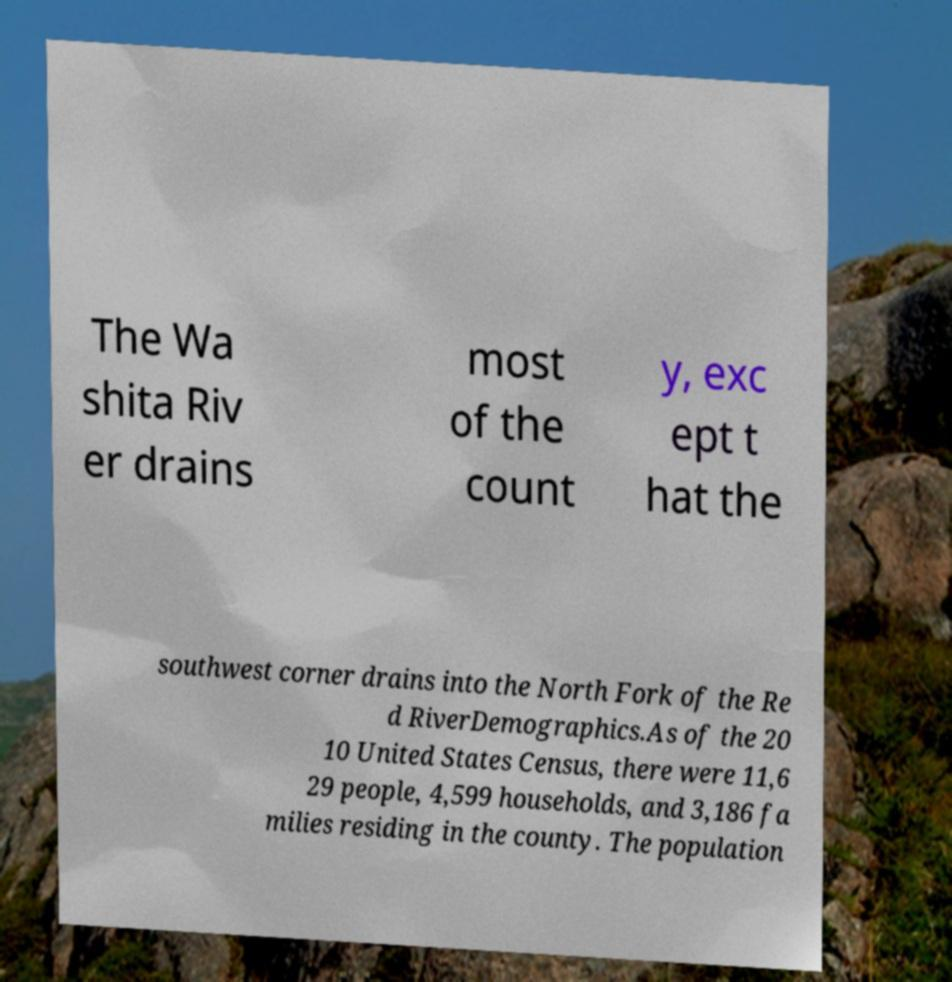I need the written content from this picture converted into text. Can you do that? The Wa shita Riv er drains most of the count y, exc ept t hat the southwest corner drains into the North Fork of the Re d RiverDemographics.As of the 20 10 United States Census, there were 11,6 29 people, 4,599 households, and 3,186 fa milies residing in the county. The population 